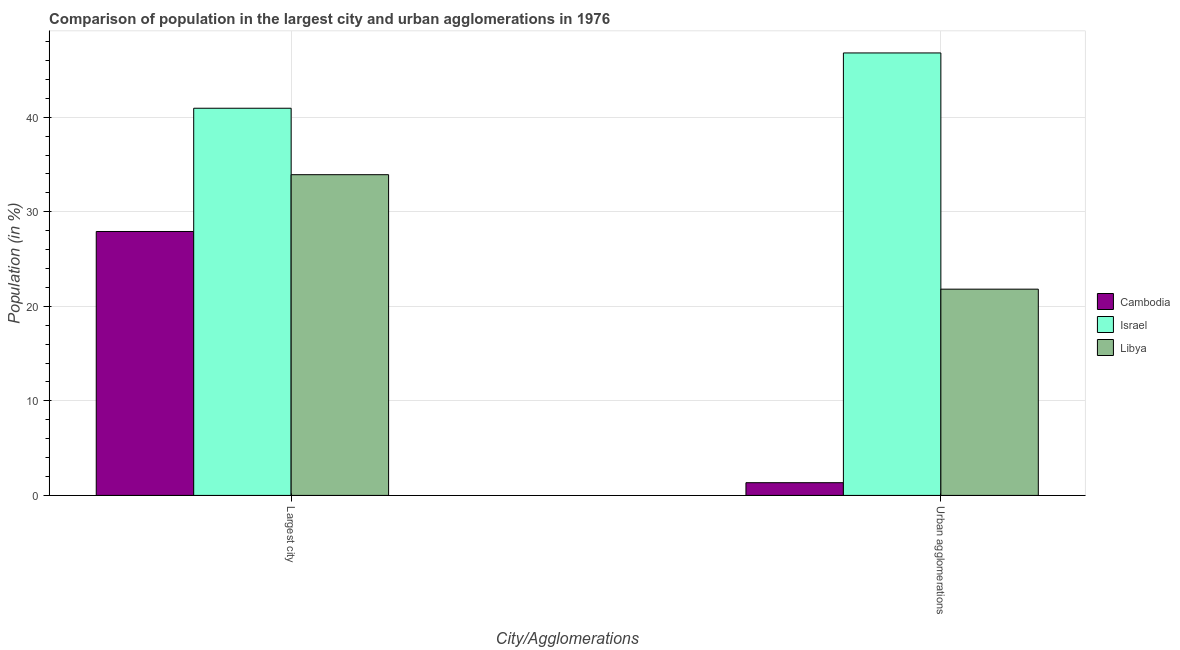How many groups of bars are there?
Make the answer very short. 2. Are the number of bars on each tick of the X-axis equal?
Your answer should be very brief. Yes. How many bars are there on the 2nd tick from the left?
Keep it short and to the point. 3. What is the label of the 2nd group of bars from the left?
Give a very brief answer. Urban agglomerations. What is the population in urban agglomerations in Libya?
Your answer should be very brief. 21.82. Across all countries, what is the maximum population in the largest city?
Your answer should be compact. 40.95. Across all countries, what is the minimum population in urban agglomerations?
Your answer should be very brief. 1.35. In which country was the population in urban agglomerations minimum?
Offer a very short reply. Cambodia. What is the total population in the largest city in the graph?
Ensure brevity in your answer.  102.8. What is the difference between the population in urban agglomerations in Libya and that in Israel?
Your response must be concise. -24.99. What is the difference between the population in the largest city in Cambodia and the population in urban agglomerations in Israel?
Offer a very short reply. -18.88. What is the average population in urban agglomerations per country?
Your answer should be very brief. 23.32. What is the difference between the population in urban agglomerations and population in the largest city in Israel?
Provide a succinct answer. 5.85. What is the ratio of the population in urban agglomerations in Cambodia to that in Libya?
Offer a very short reply. 0.06. Is the population in urban agglomerations in Israel less than that in Libya?
Offer a terse response. No. In how many countries, is the population in urban agglomerations greater than the average population in urban agglomerations taken over all countries?
Offer a very short reply. 1. What does the 1st bar from the left in Urban agglomerations represents?
Provide a succinct answer. Cambodia. What does the 1st bar from the right in Urban agglomerations represents?
Provide a short and direct response. Libya. How many bars are there?
Provide a succinct answer. 6. How many countries are there in the graph?
Your answer should be very brief. 3. What is the difference between two consecutive major ticks on the Y-axis?
Your answer should be very brief. 10. Are the values on the major ticks of Y-axis written in scientific E-notation?
Keep it short and to the point. No. How many legend labels are there?
Offer a terse response. 3. What is the title of the graph?
Provide a short and direct response. Comparison of population in the largest city and urban agglomerations in 1976. Does "Arab World" appear as one of the legend labels in the graph?
Ensure brevity in your answer.  No. What is the label or title of the X-axis?
Provide a short and direct response. City/Agglomerations. What is the Population (in %) in Cambodia in Largest city?
Provide a succinct answer. 27.92. What is the Population (in %) of Israel in Largest city?
Your answer should be very brief. 40.95. What is the Population (in %) of Libya in Largest city?
Your answer should be compact. 33.93. What is the Population (in %) of Cambodia in Urban agglomerations?
Your response must be concise. 1.35. What is the Population (in %) in Israel in Urban agglomerations?
Your response must be concise. 46.8. What is the Population (in %) of Libya in Urban agglomerations?
Provide a short and direct response. 21.82. Across all City/Agglomerations, what is the maximum Population (in %) of Cambodia?
Offer a terse response. 27.92. Across all City/Agglomerations, what is the maximum Population (in %) of Israel?
Keep it short and to the point. 46.8. Across all City/Agglomerations, what is the maximum Population (in %) of Libya?
Offer a terse response. 33.93. Across all City/Agglomerations, what is the minimum Population (in %) in Cambodia?
Your answer should be compact. 1.35. Across all City/Agglomerations, what is the minimum Population (in %) in Israel?
Your response must be concise. 40.95. Across all City/Agglomerations, what is the minimum Population (in %) in Libya?
Offer a terse response. 21.82. What is the total Population (in %) in Cambodia in the graph?
Keep it short and to the point. 29.26. What is the total Population (in %) of Israel in the graph?
Make the answer very short. 87.76. What is the total Population (in %) of Libya in the graph?
Keep it short and to the point. 55.74. What is the difference between the Population (in %) in Cambodia in Largest city and that in Urban agglomerations?
Offer a terse response. 26.57. What is the difference between the Population (in %) in Israel in Largest city and that in Urban agglomerations?
Provide a short and direct response. -5.85. What is the difference between the Population (in %) in Libya in Largest city and that in Urban agglomerations?
Give a very brief answer. 12.11. What is the difference between the Population (in %) in Cambodia in Largest city and the Population (in %) in Israel in Urban agglomerations?
Your response must be concise. -18.89. What is the difference between the Population (in %) in Cambodia in Largest city and the Population (in %) in Libya in Urban agglomerations?
Give a very brief answer. 6.1. What is the difference between the Population (in %) of Israel in Largest city and the Population (in %) of Libya in Urban agglomerations?
Keep it short and to the point. 19.14. What is the average Population (in %) in Cambodia per City/Agglomerations?
Offer a very short reply. 14.63. What is the average Population (in %) in Israel per City/Agglomerations?
Offer a very short reply. 43.88. What is the average Population (in %) in Libya per City/Agglomerations?
Give a very brief answer. 27.87. What is the difference between the Population (in %) in Cambodia and Population (in %) in Israel in Largest city?
Ensure brevity in your answer.  -13.04. What is the difference between the Population (in %) of Cambodia and Population (in %) of Libya in Largest city?
Give a very brief answer. -6.01. What is the difference between the Population (in %) in Israel and Population (in %) in Libya in Largest city?
Offer a very short reply. 7.03. What is the difference between the Population (in %) in Cambodia and Population (in %) in Israel in Urban agglomerations?
Make the answer very short. -45.46. What is the difference between the Population (in %) of Cambodia and Population (in %) of Libya in Urban agglomerations?
Your answer should be compact. -20.47. What is the difference between the Population (in %) in Israel and Population (in %) in Libya in Urban agglomerations?
Ensure brevity in your answer.  24.99. What is the ratio of the Population (in %) of Cambodia in Largest city to that in Urban agglomerations?
Provide a short and direct response. 20.75. What is the ratio of the Population (in %) in Israel in Largest city to that in Urban agglomerations?
Offer a very short reply. 0.88. What is the ratio of the Population (in %) of Libya in Largest city to that in Urban agglomerations?
Your answer should be very brief. 1.55. What is the difference between the highest and the second highest Population (in %) in Cambodia?
Offer a terse response. 26.57. What is the difference between the highest and the second highest Population (in %) in Israel?
Your answer should be very brief. 5.85. What is the difference between the highest and the second highest Population (in %) of Libya?
Offer a very short reply. 12.11. What is the difference between the highest and the lowest Population (in %) of Cambodia?
Provide a succinct answer. 26.57. What is the difference between the highest and the lowest Population (in %) of Israel?
Provide a short and direct response. 5.85. What is the difference between the highest and the lowest Population (in %) in Libya?
Ensure brevity in your answer.  12.11. 